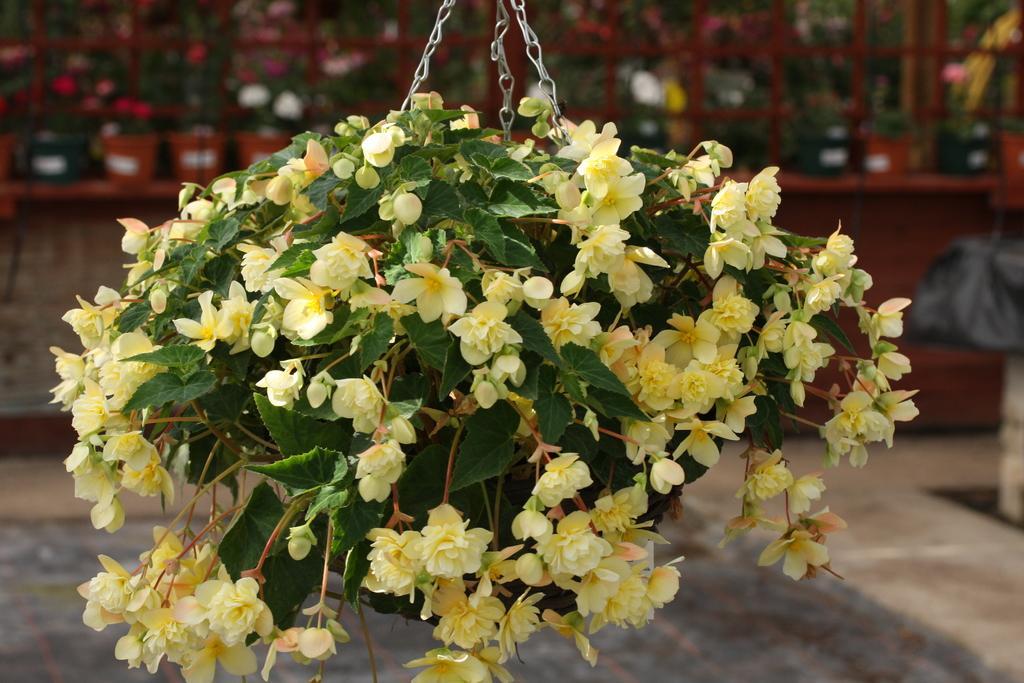Could you give a brief overview of what you see in this image? In this image I can see number of yellow colour flowers and green leaves in the front. In the background I can see few more flowers and I can see this image is little bit blurry in the background. 